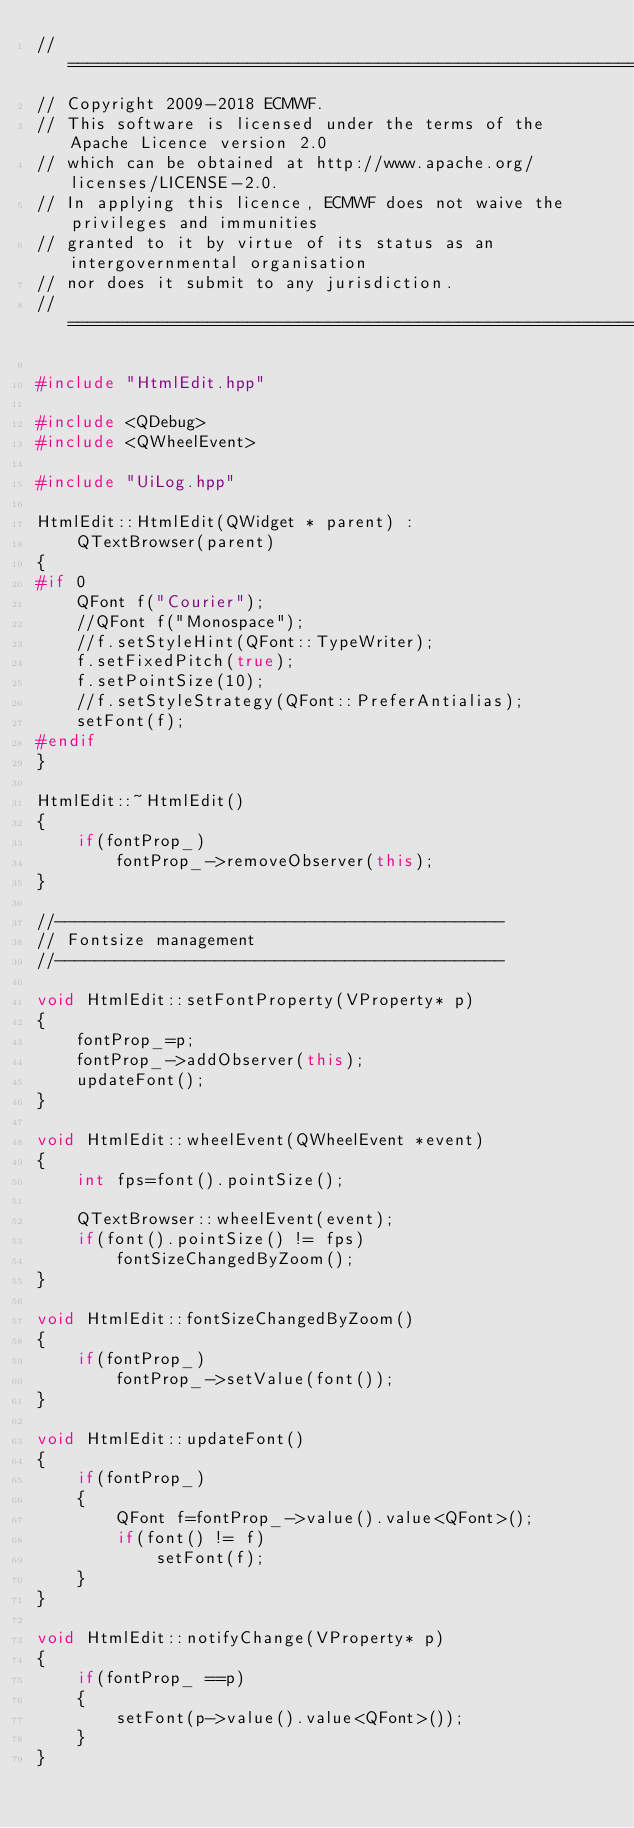<code> <loc_0><loc_0><loc_500><loc_500><_C++_>//============================================================================
// Copyright 2009-2018 ECMWF.
// This software is licensed under the terms of the Apache Licence version 2.0
// which can be obtained at http://www.apache.org/licenses/LICENSE-2.0.
// In applying this licence, ECMWF does not waive the privileges and immunities
// granted to it by virtue of its status as an intergovernmental organisation
// nor does it submit to any jurisdiction.
//============================================================================

#include "HtmlEdit.hpp"

#include <QDebug>
#include <QWheelEvent>

#include "UiLog.hpp"

HtmlEdit::HtmlEdit(QWidget * parent) :
    QTextBrowser(parent)
{
#if 0
    QFont f("Courier");
    //QFont f("Monospace");
    //f.setStyleHint(QFont::TypeWriter);
    f.setFixedPitch(true);
    f.setPointSize(10);
    //f.setStyleStrategy(QFont::PreferAntialias);
    setFont(f);
#endif
}

HtmlEdit::~HtmlEdit()
{
    if(fontProp_)
        fontProp_->removeObserver(this);
}

//---------------------------------------------
// Fontsize management
//---------------------------------------------

void HtmlEdit::setFontProperty(VProperty* p)
{
    fontProp_=p;
    fontProp_->addObserver(this);
    updateFont();
}

void HtmlEdit::wheelEvent(QWheelEvent *event)
{
    int fps=font().pointSize();

    QTextBrowser::wheelEvent(event);
    if(font().pointSize() != fps)
        fontSizeChangedByZoom();
}

void HtmlEdit::fontSizeChangedByZoom()
{
    if(fontProp_)
        fontProp_->setValue(font());
}

void HtmlEdit::updateFont()
{
    if(fontProp_)
    {
        QFont f=fontProp_->value().value<QFont>();
        if(font() != f)
            setFont(f);
    }
}

void HtmlEdit::notifyChange(VProperty* p)
{
    if(fontProp_ ==p)
    {
        setFont(p->value().value<QFont>());
    }
}
</code> 